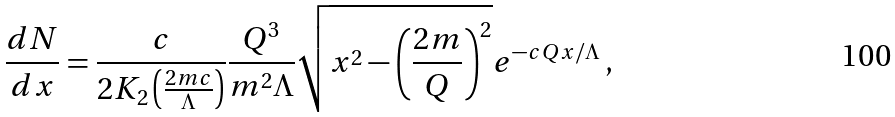<formula> <loc_0><loc_0><loc_500><loc_500>\frac { d N } { d x } = \frac { c } { 2 K _ { 2 } \left ( \frac { 2 m c } { \Lambda } \right ) } \frac { Q ^ { 3 } } { m ^ { 2 } \Lambda } \sqrt { x ^ { 2 } - \left ( \frac { 2 m } { Q } \right ) ^ { 2 } } e ^ { - c Q x / \Lambda } \, ,</formula> 